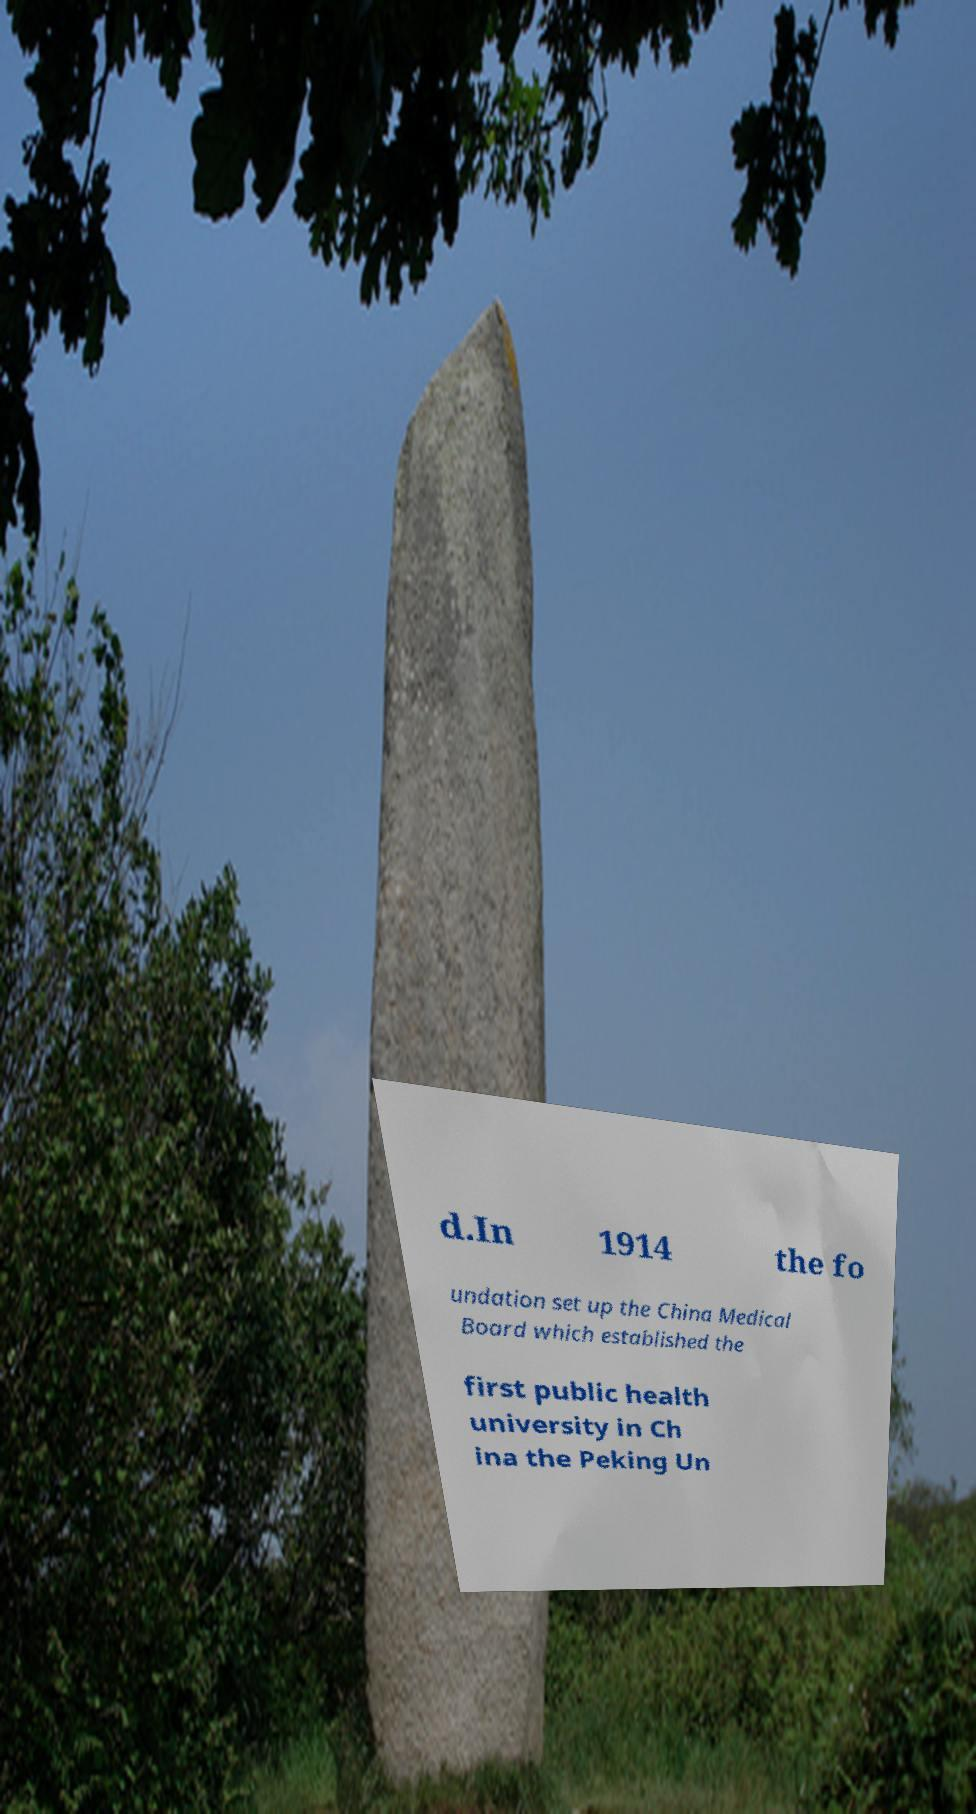Can you read and provide the text displayed in the image?This photo seems to have some interesting text. Can you extract and type it out for me? d.In 1914 the fo undation set up the China Medical Board which established the first public health university in Ch ina the Peking Un 